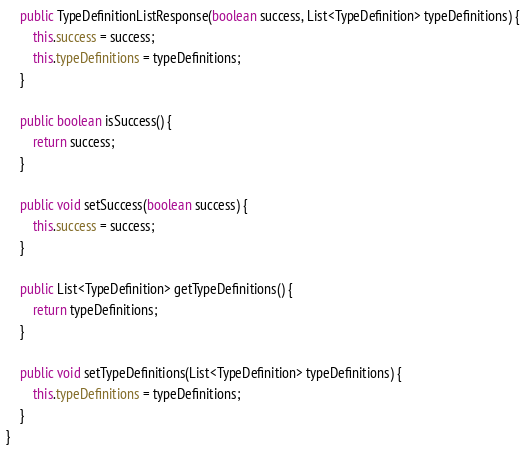<code> <loc_0><loc_0><loc_500><loc_500><_Java_>	public TypeDefinitionListResponse(boolean success, List<TypeDefinition> typeDefinitions) {
		this.success = success;
		this.typeDefinitions = typeDefinitions;
	}

	public boolean isSuccess() {
		return success;
	}

	public void setSuccess(boolean success) {
		this.success = success;
	}

	public List<TypeDefinition> getTypeDefinitions() {
		return typeDefinitions;
	}

	public void setTypeDefinitions(List<TypeDefinition> typeDefinitions) {
		this.typeDefinitions = typeDefinitions;
	}
}
</code> 